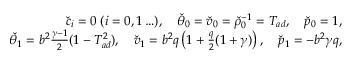<formula> <loc_0><loc_0><loc_500><loc_500>\begin{array} { r } { \check { c } _ { i } = 0 \, ( i = 0 , 1 \dots ) , \quad \check { \theta } _ { 0 } = \check { v } _ { 0 } = \check { \rho } _ { 0 } ^ { - 1 } = T _ { a d } , \quad \check { p } _ { 0 } = 1 , } \\ { \check { \theta } _ { 1 } = b ^ { 2 } \frac { \gamma - 1 } { 2 } ( 1 - T _ { a d } ^ { 2 } ) , \quad \check { v } _ { 1 } = b ^ { 2 } q \left ( 1 + \frac { q } { 2 } ( 1 + \gamma ) \right ) , \quad \check { p } _ { 1 } = - b ^ { 2 } \gamma q , } \end{array}</formula> 